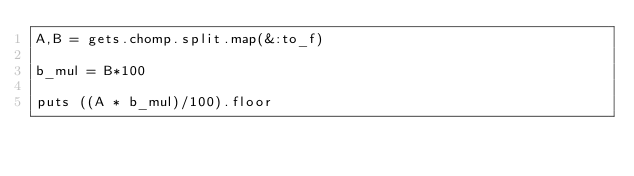Convert code to text. <code><loc_0><loc_0><loc_500><loc_500><_Ruby_>A,B = gets.chomp.split.map(&:to_f)

b_mul = B*100

puts ((A * b_mul)/100).floor
</code> 